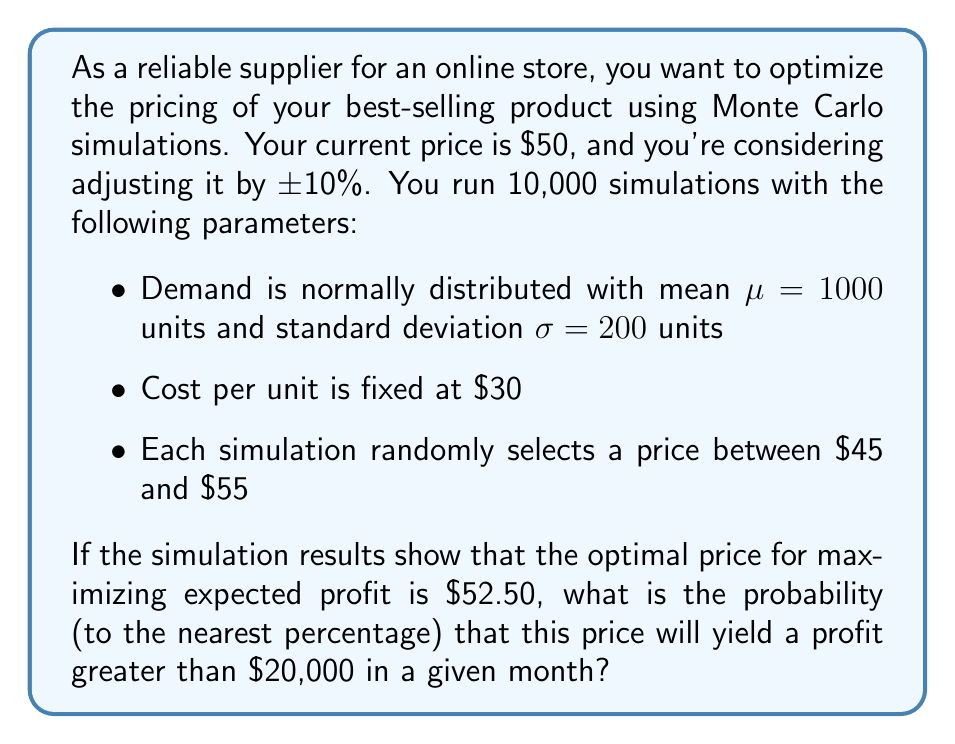Show me your answer to this math problem. To solve this problem, we'll follow these steps:

1) First, we need to calculate the expected demand at the optimal price. We can use the concept of price elasticity, but since we don't have that information, we'll assume the demand remains constant at the mean of 1000 units.

2) Calculate the expected profit at the optimal price:
   Profit = Revenue - Cost
   $$\text{Profit} = (52.50 \times 1000) - (30 \times 1000) = 52,500 - 30,000 = 22,500$$

3) To find the probability of profit exceeding $20,000, we need to determine the standard deviation of profit. The variability in profit comes from the variability in demand.

4) Calculate the standard deviation of profit:
   $$\sigma_{\text{profit}} = (52.50 - 30) \times 200 = 4,500$$

5) Calculate the z-score for a profit of $20,000:
   $$z = \frac{20,000 - 22,500}{4,500} = -0.5556$$

6) Use the standard normal distribution to find the probability of exceeding this z-score:
   $$P(Z > -0.5556) = 1 - P(Z < -0.5556) = 1 - 0.2893 = 0.7107$$

7) Convert to a percentage and round to the nearest whole number:
   0.7107 × 100 ≈ 71%
Answer: 71% 